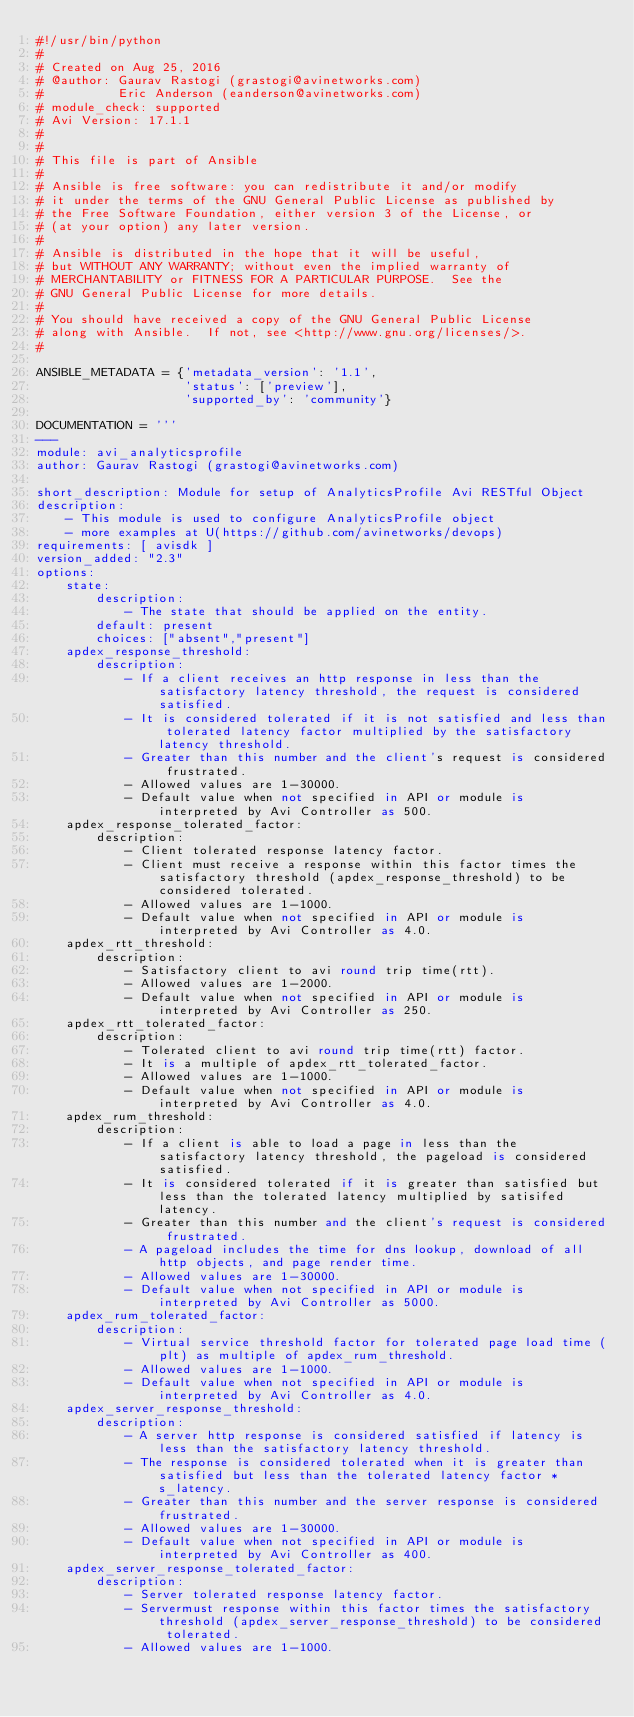<code> <loc_0><loc_0><loc_500><loc_500><_Python_>#!/usr/bin/python
#
# Created on Aug 25, 2016
# @author: Gaurav Rastogi (grastogi@avinetworks.com)
#          Eric Anderson (eanderson@avinetworks.com)
# module_check: supported
# Avi Version: 17.1.1
#
#
# This file is part of Ansible
#
# Ansible is free software: you can redistribute it and/or modify
# it under the terms of the GNU General Public License as published by
# the Free Software Foundation, either version 3 of the License, or
# (at your option) any later version.
#
# Ansible is distributed in the hope that it will be useful,
# but WITHOUT ANY WARRANTY; without even the implied warranty of
# MERCHANTABILITY or FITNESS FOR A PARTICULAR PURPOSE.  See the
# GNU General Public License for more details.
#
# You should have received a copy of the GNU General Public License
# along with Ansible.  If not, see <http://www.gnu.org/licenses/>.
#

ANSIBLE_METADATA = {'metadata_version': '1.1',
                    'status': ['preview'],
                    'supported_by': 'community'}

DOCUMENTATION = '''
---
module: avi_analyticsprofile
author: Gaurav Rastogi (grastogi@avinetworks.com)

short_description: Module for setup of AnalyticsProfile Avi RESTful Object
description:
    - This module is used to configure AnalyticsProfile object
    - more examples at U(https://github.com/avinetworks/devops)
requirements: [ avisdk ]
version_added: "2.3"
options:
    state:
        description:
            - The state that should be applied on the entity.
        default: present
        choices: ["absent","present"]
    apdex_response_threshold:
        description:
            - If a client receives an http response in less than the satisfactory latency threshold, the request is considered satisfied.
            - It is considered tolerated if it is not satisfied and less than tolerated latency factor multiplied by the satisfactory latency threshold.
            - Greater than this number and the client's request is considered frustrated.
            - Allowed values are 1-30000.
            - Default value when not specified in API or module is interpreted by Avi Controller as 500.
    apdex_response_tolerated_factor:
        description:
            - Client tolerated response latency factor.
            - Client must receive a response within this factor times the satisfactory threshold (apdex_response_threshold) to be considered tolerated.
            - Allowed values are 1-1000.
            - Default value when not specified in API or module is interpreted by Avi Controller as 4.0.
    apdex_rtt_threshold:
        description:
            - Satisfactory client to avi round trip time(rtt).
            - Allowed values are 1-2000.
            - Default value when not specified in API or module is interpreted by Avi Controller as 250.
    apdex_rtt_tolerated_factor:
        description:
            - Tolerated client to avi round trip time(rtt) factor.
            - It is a multiple of apdex_rtt_tolerated_factor.
            - Allowed values are 1-1000.
            - Default value when not specified in API or module is interpreted by Avi Controller as 4.0.
    apdex_rum_threshold:
        description:
            - If a client is able to load a page in less than the satisfactory latency threshold, the pageload is considered satisfied.
            - It is considered tolerated if it is greater than satisfied but less than the tolerated latency multiplied by satisifed latency.
            - Greater than this number and the client's request is considered frustrated.
            - A pageload includes the time for dns lookup, download of all http objects, and page render time.
            - Allowed values are 1-30000.
            - Default value when not specified in API or module is interpreted by Avi Controller as 5000.
    apdex_rum_tolerated_factor:
        description:
            - Virtual service threshold factor for tolerated page load time (plt) as multiple of apdex_rum_threshold.
            - Allowed values are 1-1000.
            - Default value when not specified in API or module is interpreted by Avi Controller as 4.0.
    apdex_server_response_threshold:
        description:
            - A server http response is considered satisfied if latency is less than the satisfactory latency threshold.
            - The response is considered tolerated when it is greater than satisfied but less than the tolerated latency factor * s_latency.
            - Greater than this number and the server response is considered frustrated.
            - Allowed values are 1-30000.
            - Default value when not specified in API or module is interpreted by Avi Controller as 400.
    apdex_server_response_tolerated_factor:
        description:
            - Server tolerated response latency factor.
            - Servermust response within this factor times the satisfactory threshold (apdex_server_response_threshold) to be considered tolerated.
            - Allowed values are 1-1000.</code> 